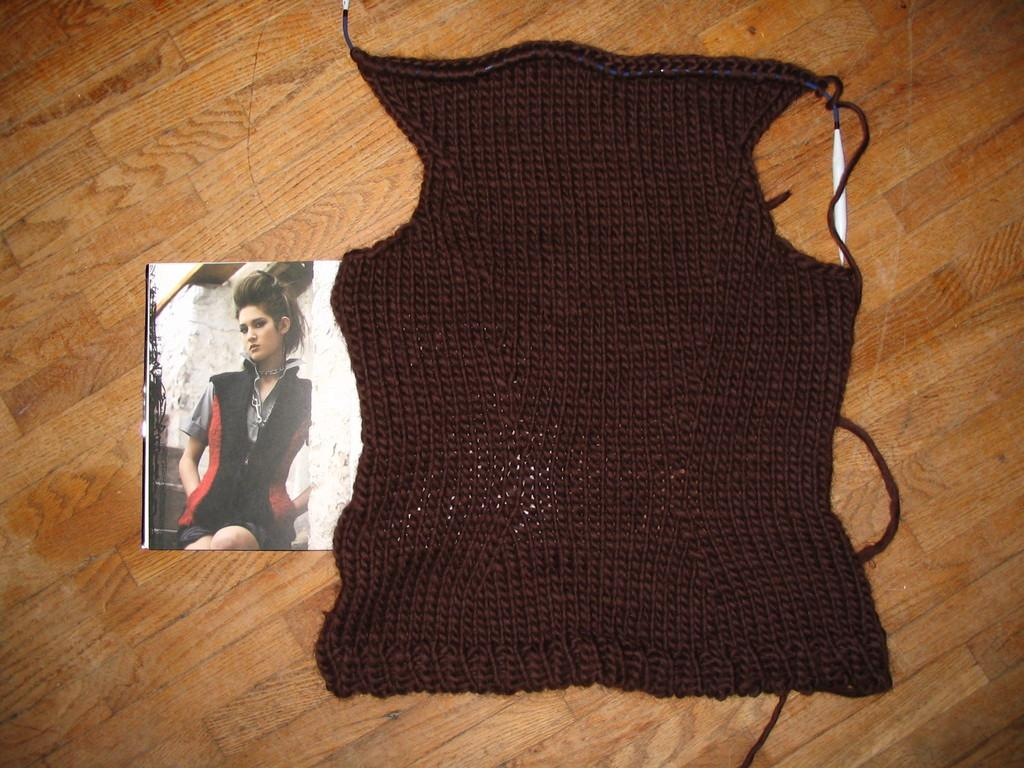What is present in the image that can be used for covering or decoration? There is a cloth in the image. What can be seen on the cloth in the image? There is a photo in the image. What is depicted in the photo? The photo contains an image of a girl. What type of surface is visible at the bottom of the image? There is a wooden surface at the bottom of the image. How does the girl in the photo taste the cloth in the image? The girl in the photo does not taste the cloth in the image, as it is a static image and cannot depict actions like tasting. 